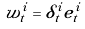<formula> <loc_0><loc_0><loc_500><loc_500>w _ { t } ^ { i } = \delta _ { t } ^ { i } e _ { t } ^ { i }</formula> 